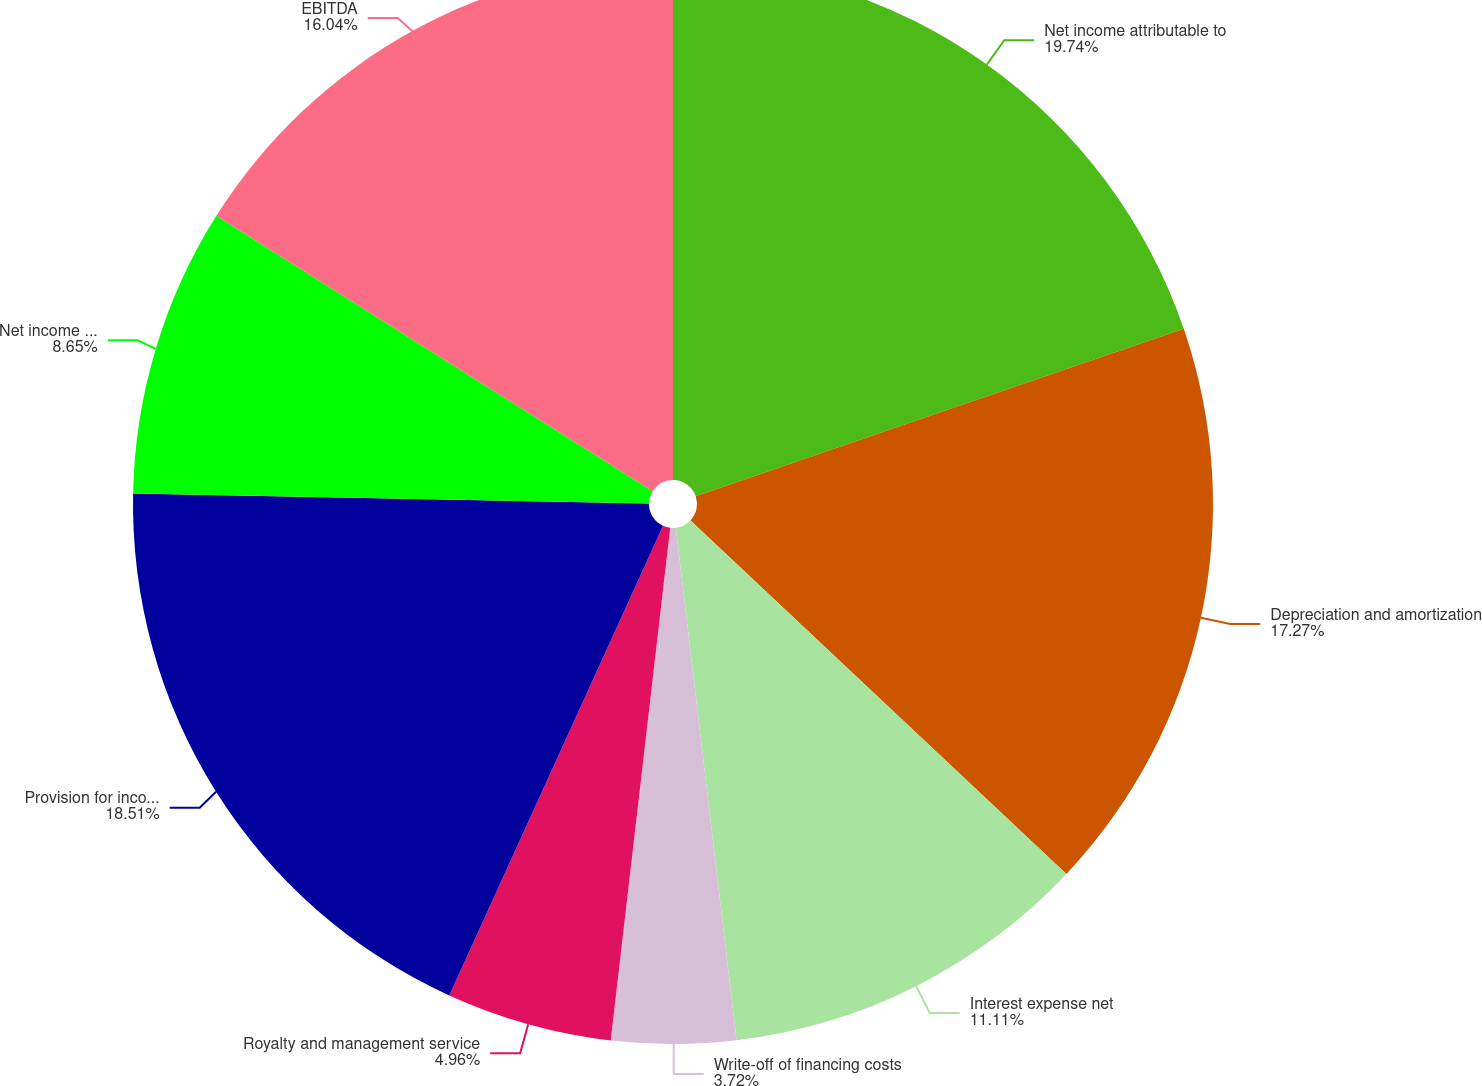Convert chart to OTSL. <chart><loc_0><loc_0><loc_500><loc_500><pie_chart><fcel>Net income attributable to<fcel>Depreciation and amortization<fcel>Interest expense net<fcel>Write-off of financing costs<fcel>Royalty and management service<fcel>Provision for income taxes<fcel>Net income (loss) attributable<fcel>EBITDA<nl><fcel>19.74%<fcel>17.27%<fcel>11.11%<fcel>3.72%<fcel>4.96%<fcel>18.51%<fcel>8.65%<fcel>16.04%<nl></chart> 